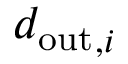Convert formula to latex. <formula><loc_0><loc_0><loc_500><loc_500>{ d _ { o u t } } _ { , i }</formula> 